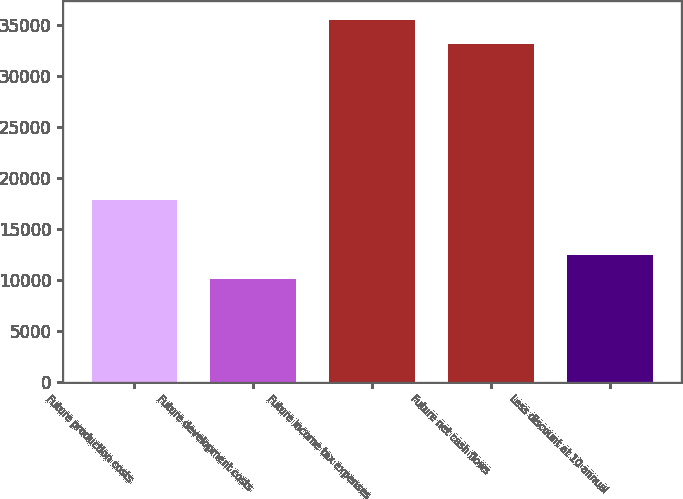Convert chart. <chart><loc_0><loc_0><loc_500><loc_500><bar_chart><fcel>Future production costs<fcel>Future development costs<fcel>Future income tax expenses<fcel>Future net cash flows<fcel>Less discount at 10 annual<nl><fcel>17862<fcel>10118<fcel>35513.5<fcel>33142<fcel>12489.5<nl></chart> 